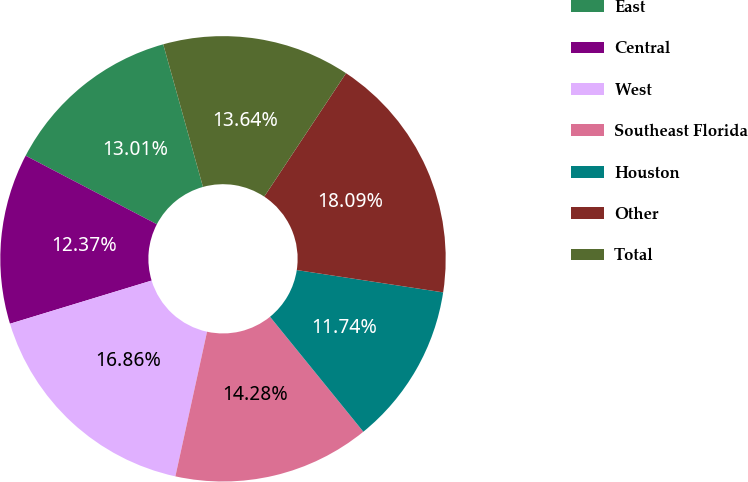<chart> <loc_0><loc_0><loc_500><loc_500><pie_chart><fcel>East<fcel>Central<fcel>West<fcel>Southeast Florida<fcel>Houston<fcel>Other<fcel>Total<nl><fcel>13.01%<fcel>12.37%<fcel>16.86%<fcel>14.28%<fcel>11.74%<fcel>18.09%<fcel>13.64%<nl></chart> 